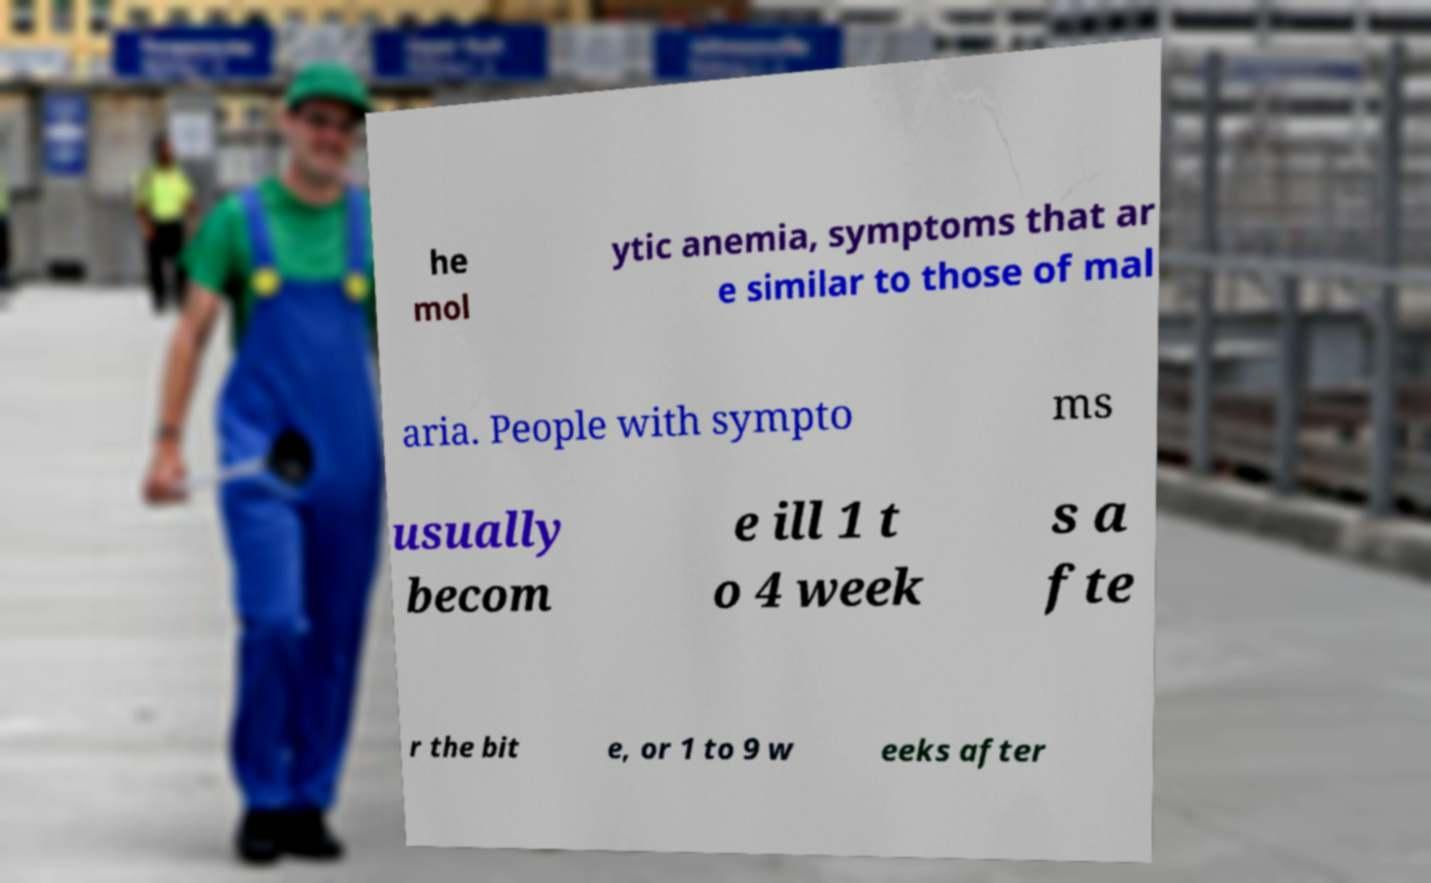Could you assist in decoding the text presented in this image and type it out clearly? he mol ytic anemia, symptoms that ar e similar to those of mal aria. People with sympto ms usually becom e ill 1 t o 4 week s a fte r the bit e, or 1 to 9 w eeks after 